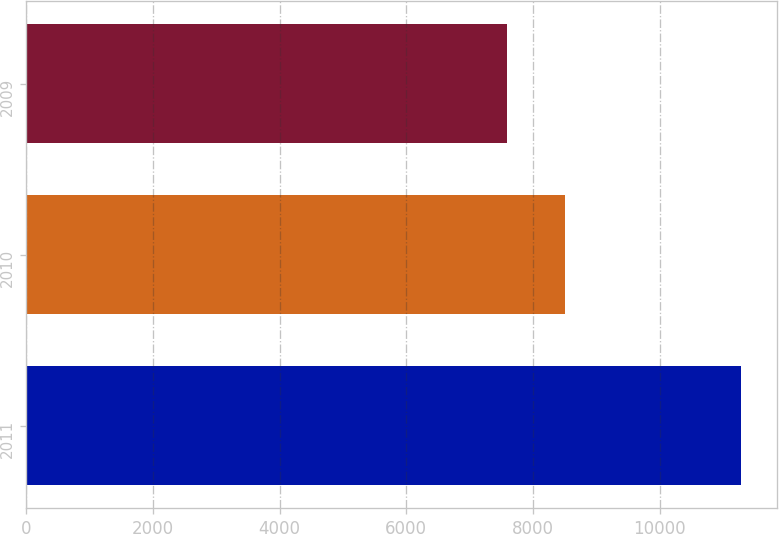<chart> <loc_0><loc_0><loc_500><loc_500><bar_chart><fcel>2011<fcel>2010<fcel>2009<nl><fcel>11287<fcel>8512<fcel>7595<nl></chart> 